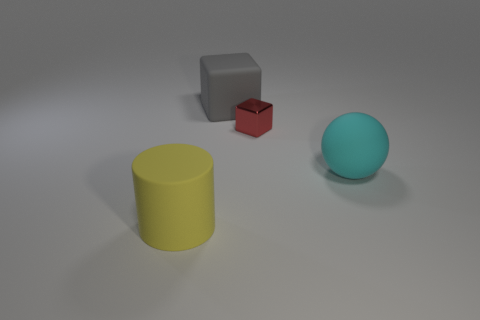Add 1 small shiny objects. How many objects exist? 5 Subtract all spheres. How many objects are left? 3 Subtract all yellow things. Subtract all large cylinders. How many objects are left? 2 Add 4 large yellow things. How many large yellow things are left? 5 Add 4 small red shiny blocks. How many small red shiny blocks exist? 5 Subtract 0 brown cylinders. How many objects are left? 4 